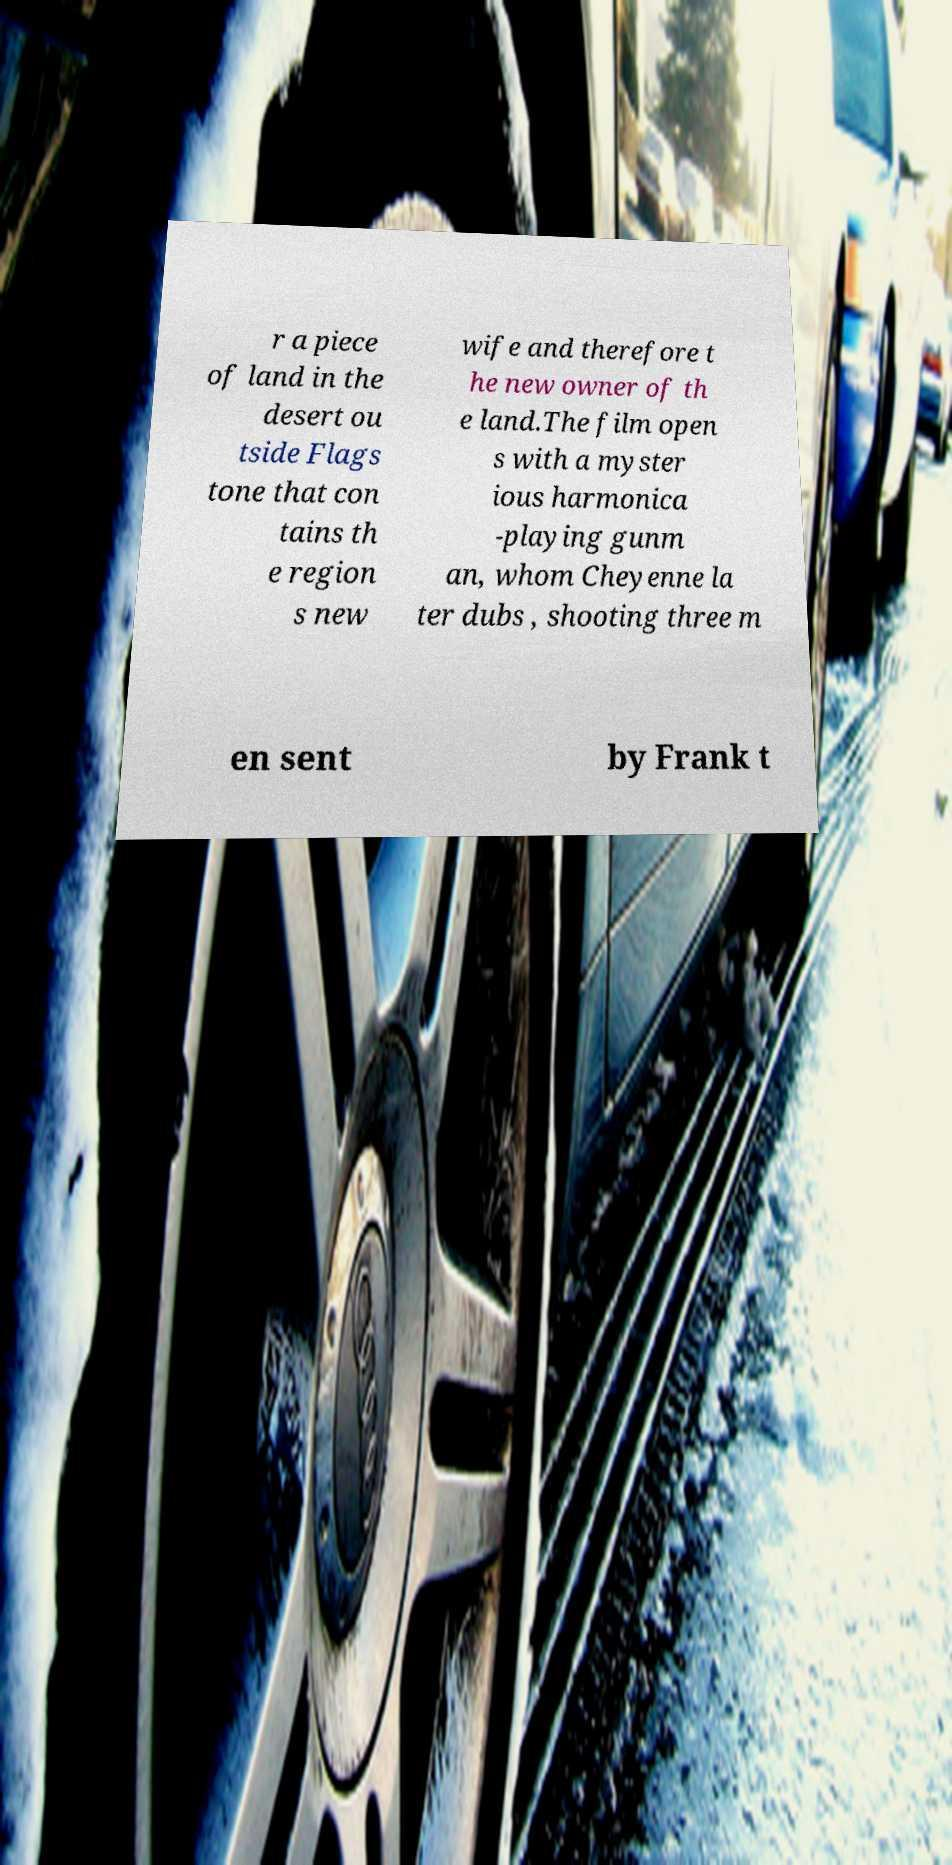I need the written content from this picture converted into text. Can you do that? r a piece of land in the desert ou tside Flags tone that con tains th e region s new wife and therefore t he new owner of th e land.The film open s with a myster ious harmonica -playing gunm an, whom Cheyenne la ter dubs , shooting three m en sent by Frank t 